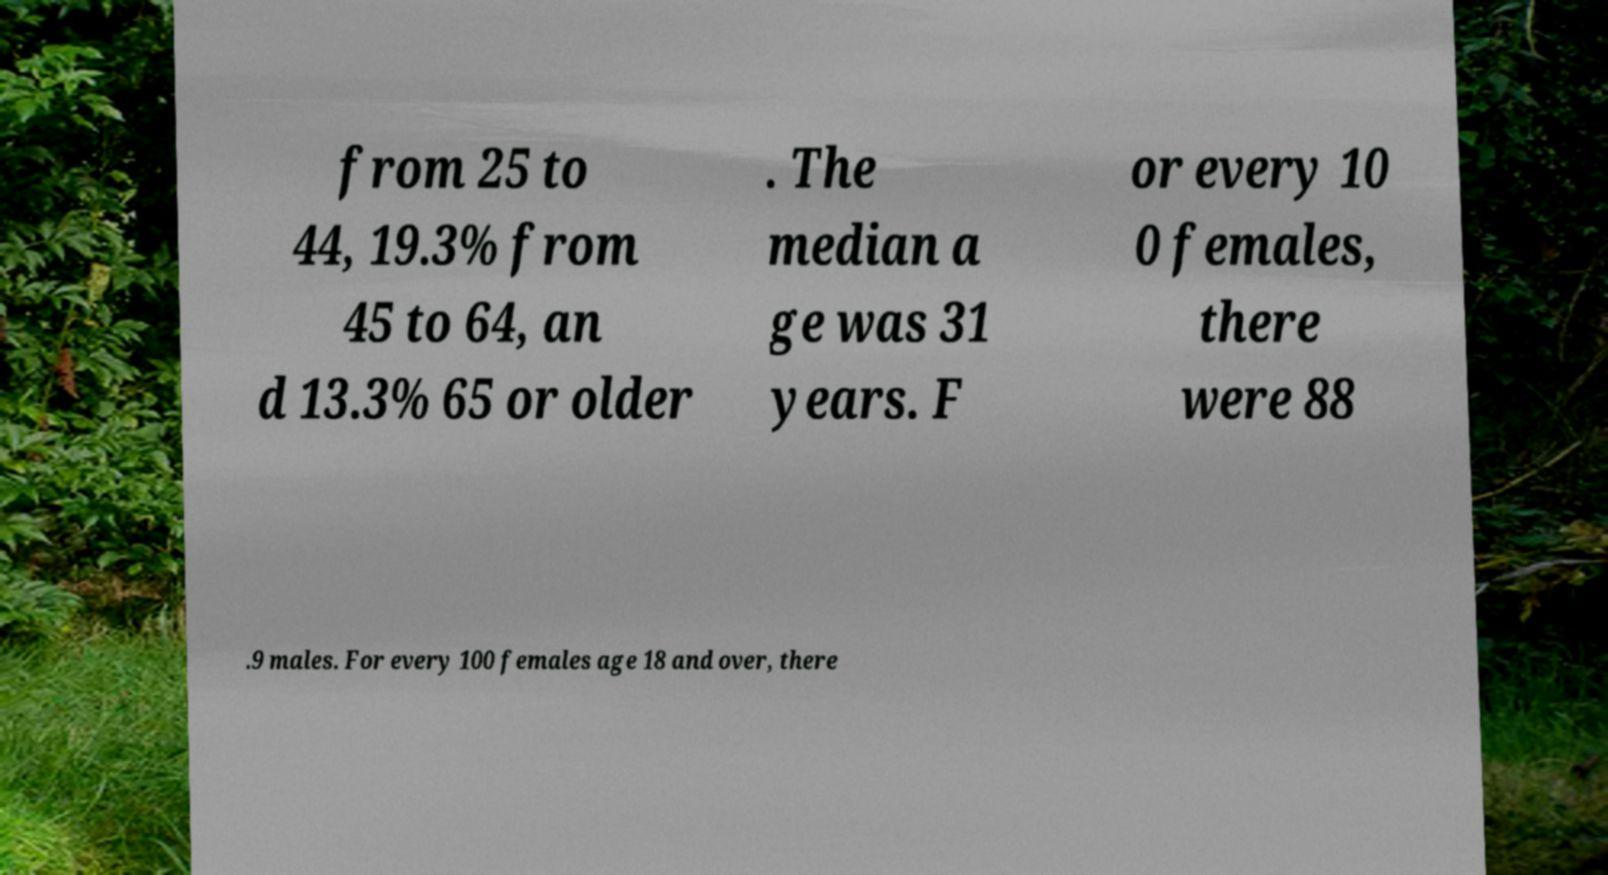Please read and relay the text visible in this image. What does it say? from 25 to 44, 19.3% from 45 to 64, an d 13.3% 65 or older . The median a ge was 31 years. F or every 10 0 females, there were 88 .9 males. For every 100 females age 18 and over, there 